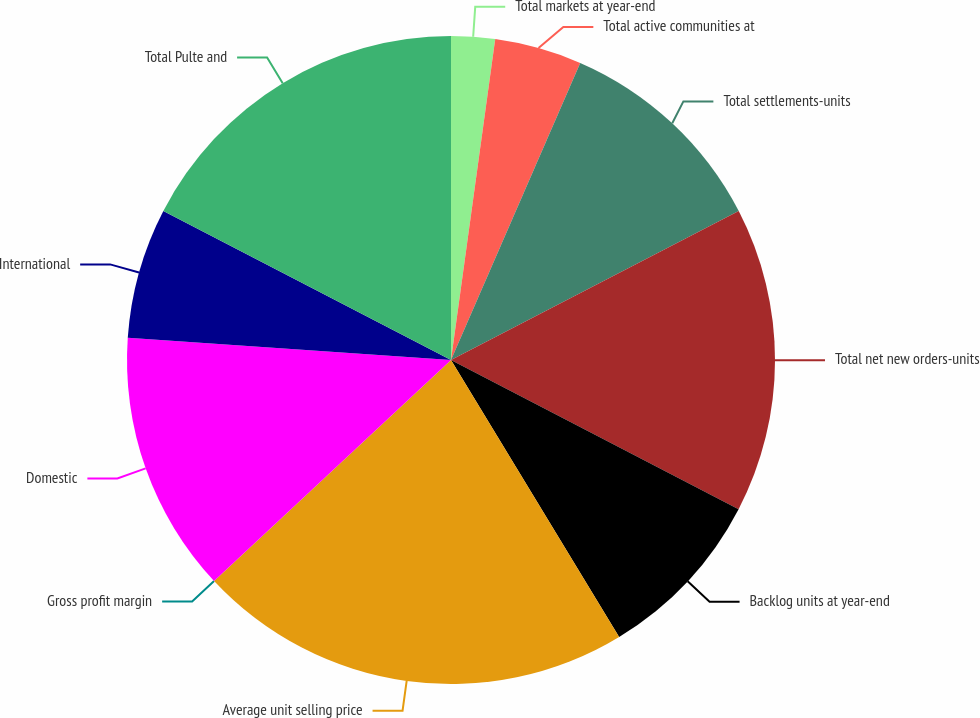<chart> <loc_0><loc_0><loc_500><loc_500><pie_chart><fcel>Total markets at year-end<fcel>Total active communities at<fcel>Total settlements-units<fcel>Total net new orders-units<fcel>Backlog units at year-end<fcel>Average unit selling price<fcel>Gross profit margin<fcel>Domestic<fcel>International<fcel>Total Pulte and<nl><fcel>2.18%<fcel>4.35%<fcel>10.87%<fcel>15.22%<fcel>8.7%<fcel>21.74%<fcel>0.0%<fcel>13.04%<fcel>6.52%<fcel>17.39%<nl></chart> 